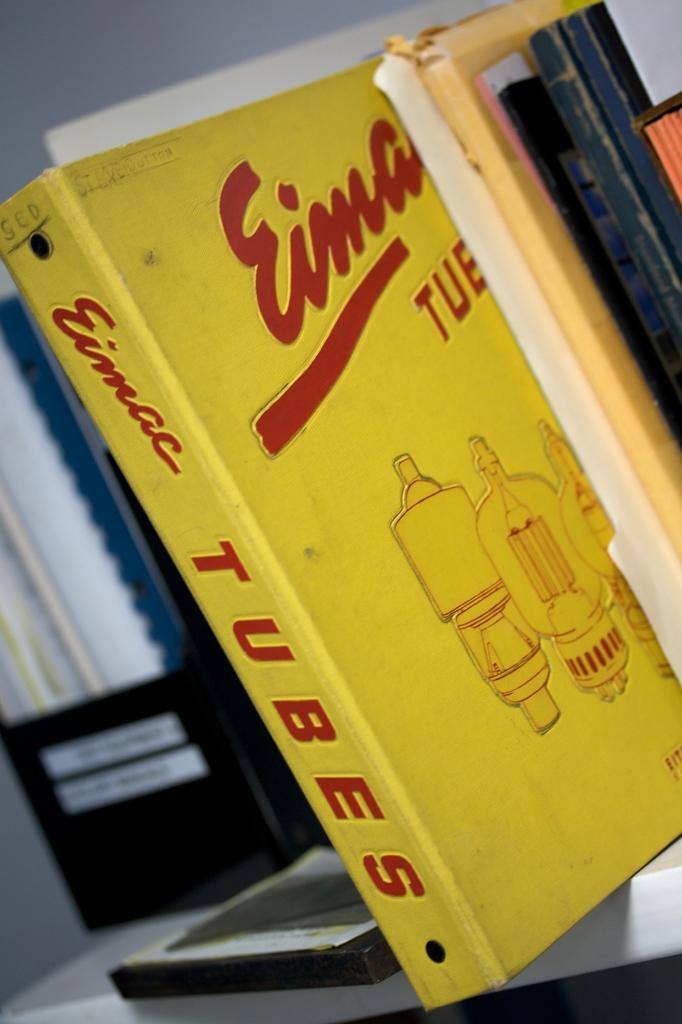What is the information in the yellow binder about?
Ensure brevity in your answer.  Tubes. 